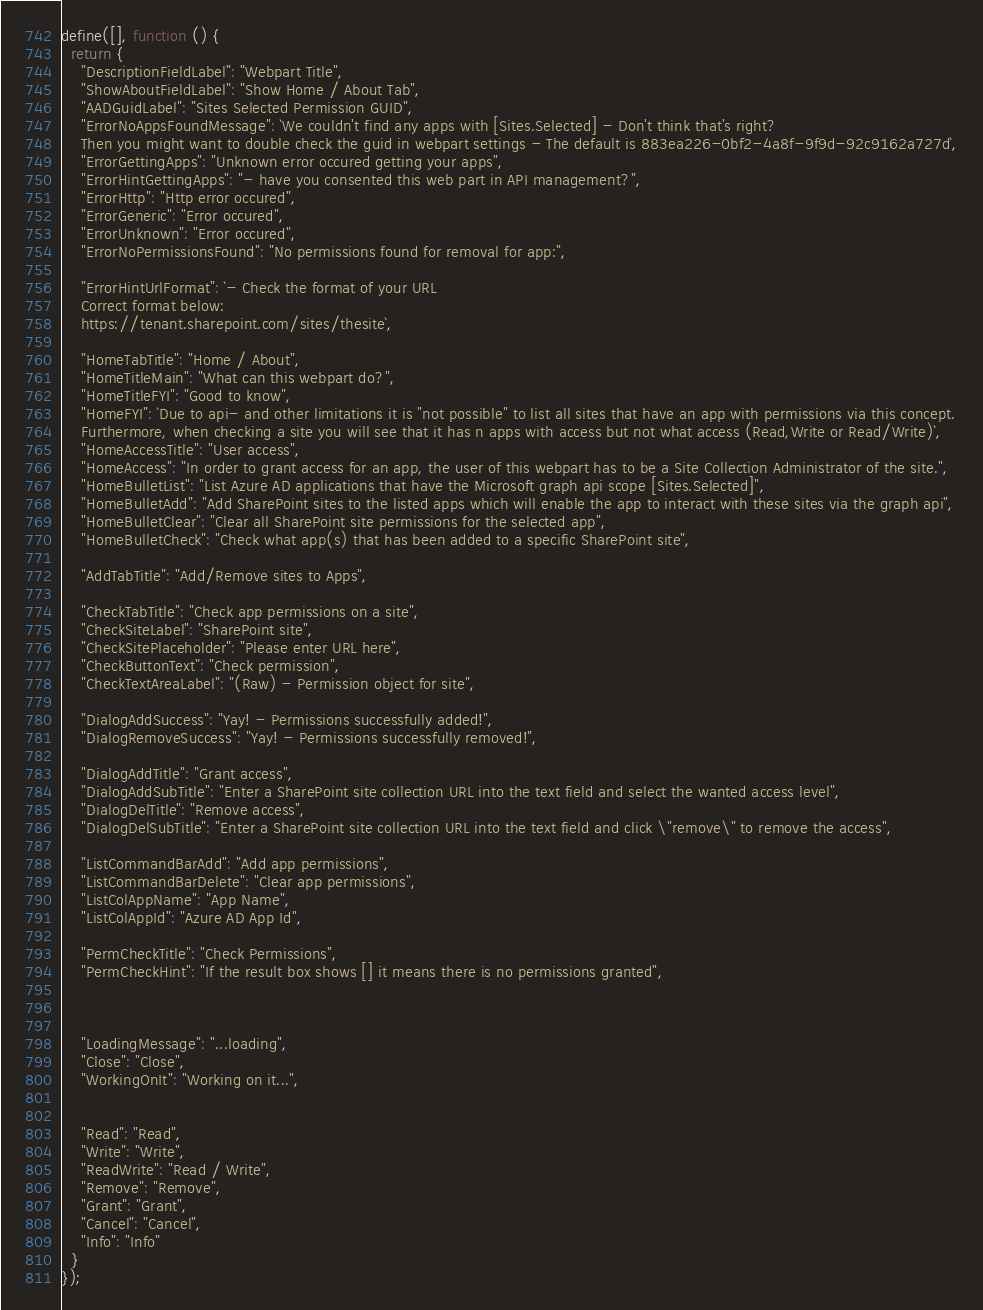Convert code to text. <code><loc_0><loc_0><loc_500><loc_500><_JavaScript_>define([], function () {
  return {
    "DescriptionFieldLabel": "Webpart Title",
    "ShowAboutFieldLabel": "Show Home / About Tab",
    "AADGuidLabel": "Sites Selected Permission GUID",
    "ErrorNoAppsFoundMessage": `We couldn't find any apps with [Sites.Selected] - Don't think that's right? 
    Then you might want to double check the guid in webpart settings - The default is 883ea226-0bf2-4a8f-9f9d-92c9162a727d`,
    "ErrorGettingApps": "Unknown error occured getting your apps",
    "ErrorHintGettingApps": "- have you consented this web part in API management?",
    "ErrorHttp": "Http error occured",
    "ErrorGeneric": "Error occured",
    "ErrorUnknown": "Error occured",
    "ErrorNoPermissionsFound": "No permissions found for removal for app:",

    "ErrorHintUrlFormat": `- Check the format of your URL
    Correct format below:
    https://tenant.sharepoint.com/sites/thesite`,

    "HomeTabTitle": "Home / About",
    "HomeTitleMain": "What can this webpart do?",
    "HomeTitleFYI": "Good to know",
    "HomeFYI": `Due to api- and other limitations it is "not possible" to list all sites that have an app with permissions via this concept.
    Furthermore, when checking a site you will see that it has n apps with access but not what access (Read,Write or Read/Write)`,
    "HomeAccessTitle": "User access",
    "HomeAccess": "In order to grant access for an app, the user of this webpart has to be a Site Collection Administrator of the site.",
    "HomeBulletList": "List Azure AD applications that have the Microsoft graph api scope [Sites.Selected]",
    "HomeBulletAdd": "Add SharePoint sites to the listed apps which will enable the app to interact with these sites via the graph api",
    "HomeBulletClear": "Clear all SharePoint site permissions for the selected app",
    "HomeBulletCheck": "Check what app(s) that has been added to a specific SharePoint site",

    "AddTabTitle": "Add/Remove sites to Apps",

    "CheckTabTitle": "Check app permissions on a site",
    "CheckSiteLabel": "SharePoint site",
    "CheckSitePlaceholder": "Please enter URL here",
    "CheckButtonText": "Check permission",
    "CheckTextAreaLabel": "(Raw) - Permission object for site",

    "DialogAddSuccess": "Yay! - Permissions successfully added!",
    "DialogRemoveSuccess": "Yay! - Permissions successfully removed!",

    "DialogAddTitle": "Grant access",
    "DialogAddSubTitle": "Enter a SharePoint site collection URL into the text field and select the wanted access level",
    "DialogDelTitle": "Remove access",
    "DialogDelSubTitle": "Enter a SharePoint site collection URL into the text field and click \"remove\" to remove the access",

    "ListCommandBarAdd": "Add app permissions",
    "ListCommandBarDelete": "Clear app permissions",
    "ListColAppName": "App Name",
    "ListColAppId": "Azure AD App Id",

    "PermCheckTitle": "Check Permissions",
    "PermCheckHint": "If the result box shows [] it means there is no permissions granted",



    "LoadingMessage": "...loading",
    "Close": "Close",
    "WorkingOnIt": "Working on it...",


    "Read": "Read",
    "Write": "Write",
    "ReadWrite": "Read / Write",
    "Remove": "Remove",
    "Grant": "Grant",
    "Cancel": "Cancel",
    "Info": "Info"
  }
});</code> 